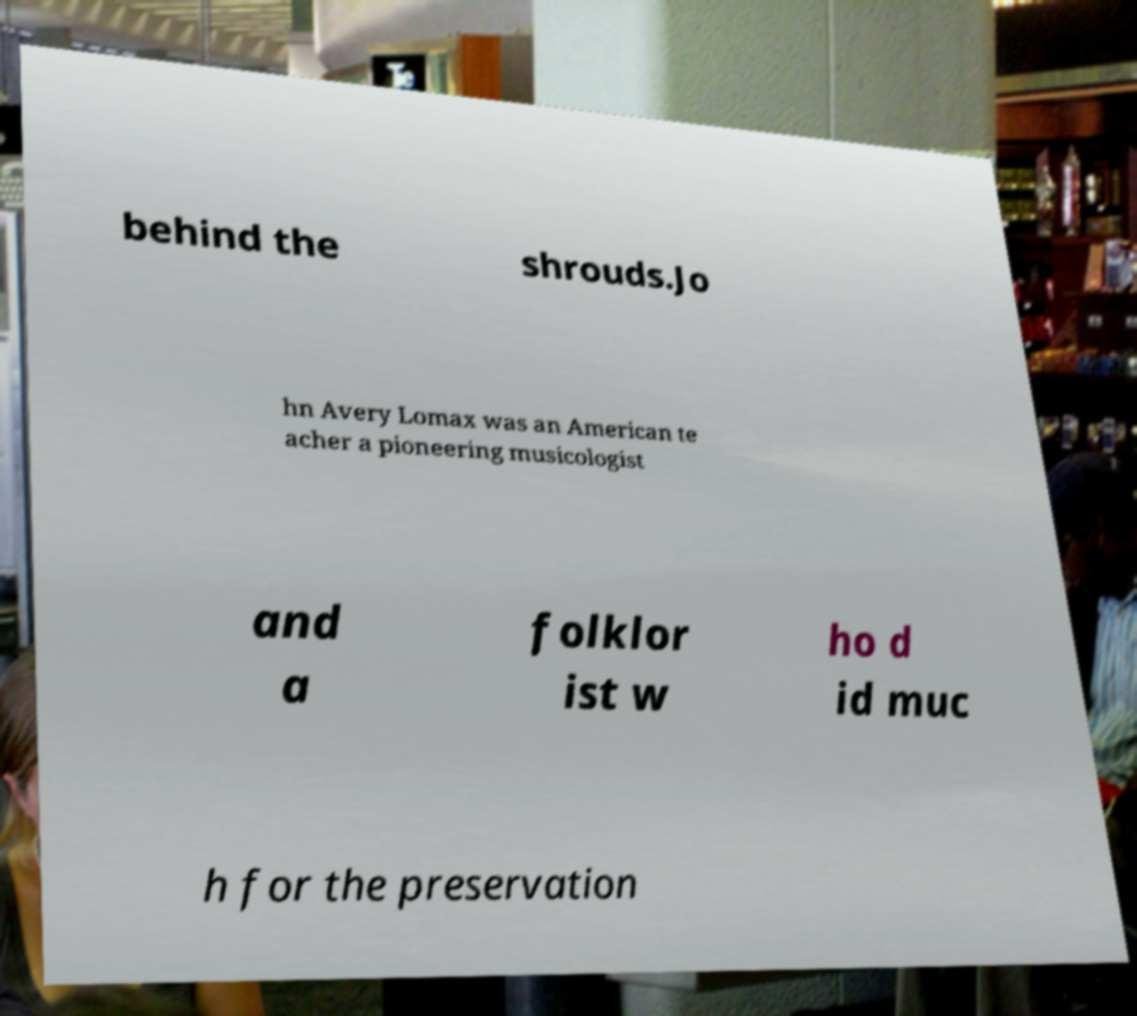For documentation purposes, I need the text within this image transcribed. Could you provide that? behind the shrouds.Jo hn Avery Lomax was an American te acher a pioneering musicologist and a folklor ist w ho d id muc h for the preservation 